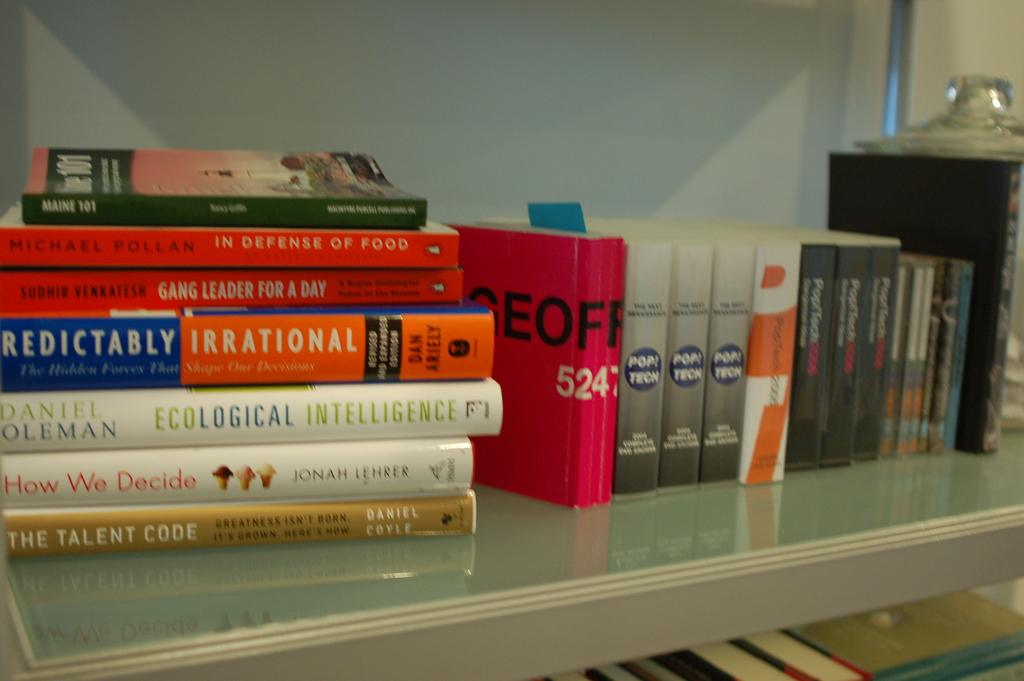<image>
Offer a succinct explanation of the picture presented. Many books on a table including one that says How We Decide. 